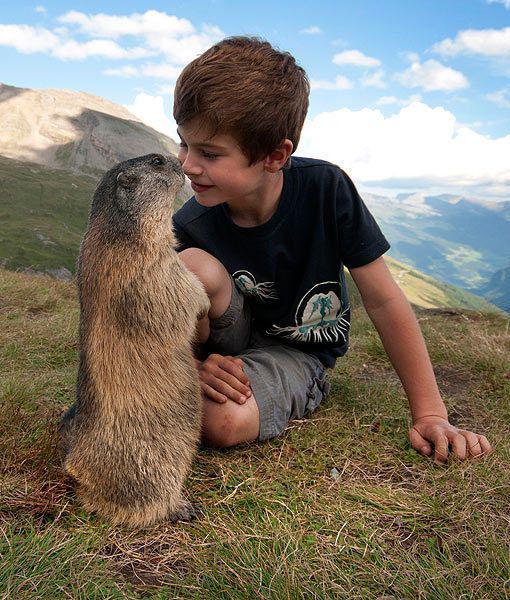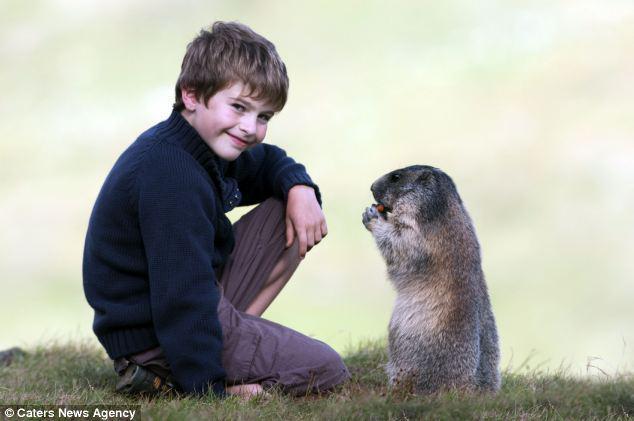The first image is the image on the left, the second image is the image on the right. Considering the images on both sides, is "There are six marmots." valid? Answer yes or no. No. The first image is the image on the left, the second image is the image on the right. Examine the images to the left and right. Is the description "In the right image, there are at least three animals interacting with a young boy." accurate? Answer yes or no. No. 